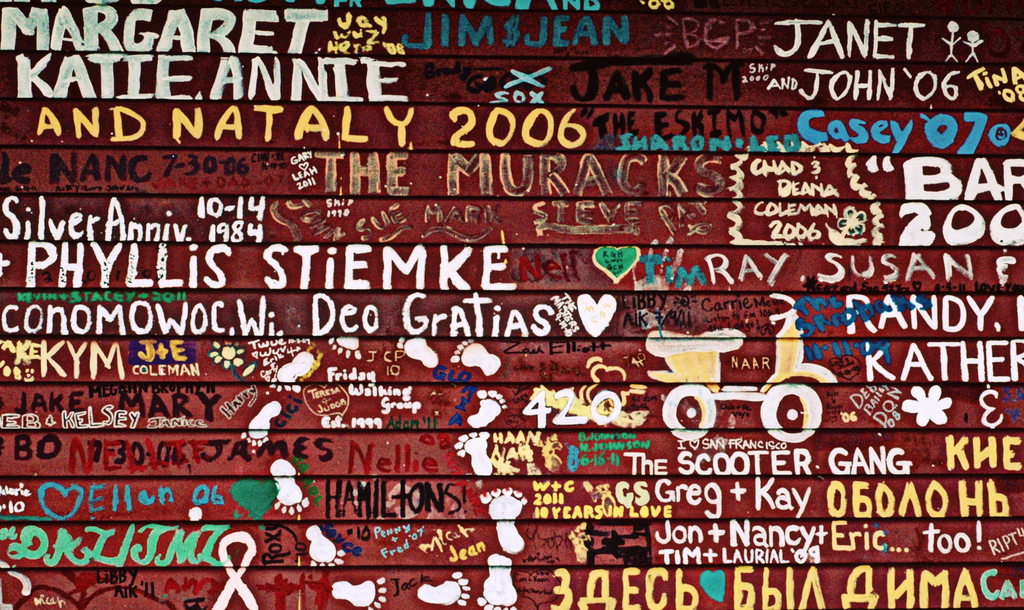Can you describe what might have inspired the style of graffiti seen in this image? The style of graffiti in the image could be inspired by a community's desire to leave a personal mark or memorialize significant events. Often, such artwork is influenced by street art culture where individuals express their identity, memories, and relationships through creative, spontaneous designs. 